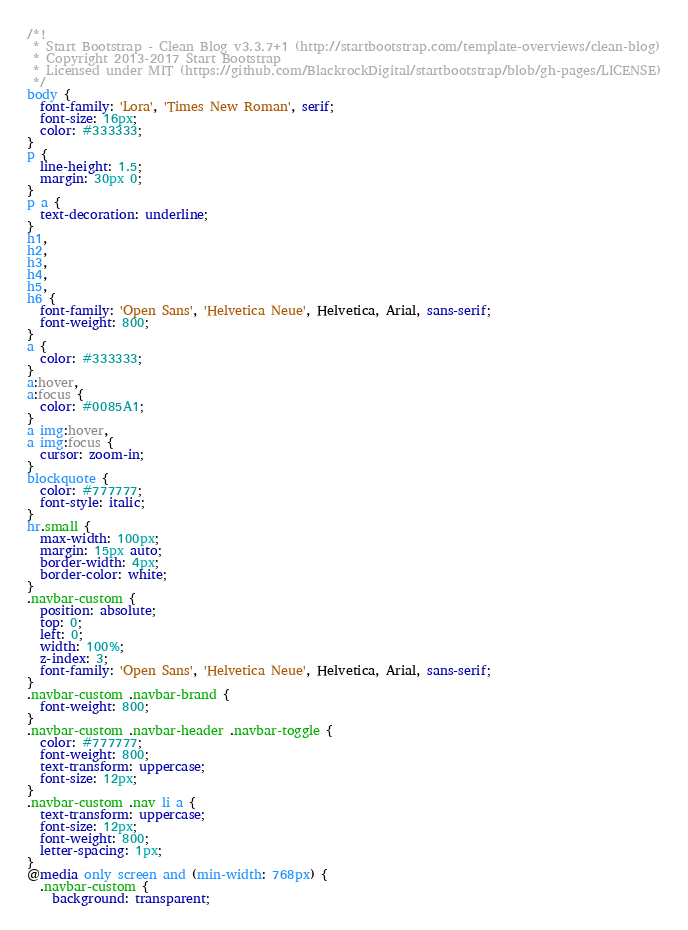<code> <loc_0><loc_0><loc_500><loc_500><_CSS_>/*!
 * Start Bootstrap - Clean Blog v3.3.7+1 (http://startbootstrap.com/template-overviews/clean-blog)
 * Copyright 2013-2017 Start Bootstrap
 * Licensed under MIT (https://github.com/BlackrockDigital/startbootstrap/blob/gh-pages/LICENSE)
 */
body {
  font-family: 'Lora', 'Times New Roman', serif;
  font-size: 16px;
  color: #333333;
}
p {
  line-height: 1.5;
  margin: 30px 0;
}
p a {
  text-decoration: underline;
}
h1,
h2,
h3,
h4,
h5,
h6 {
  font-family: 'Open Sans', 'Helvetica Neue', Helvetica, Arial, sans-serif;
  font-weight: 800;
}
a {
  color: #333333;
}
a:hover,
a:focus {
  color: #0085A1;
}
a img:hover,
a img:focus {
  cursor: zoom-in;
}
blockquote {
  color: #777777;
  font-style: italic;
}
hr.small {
  max-width: 100px;
  margin: 15px auto;
  border-width: 4px;
  border-color: white;
}
.navbar-custom {
  position: absolute;
  top: 0;
  left: 0;
  width: 100%;
  z-index: 3;
  font-family: 'Open Sans', 'Helvetica Neue', Helvetica, Arial, sans-serif;
}
.navbar-custom .navbar-brand {
  font-weight: 800;
}
.navbar-custom .navbar-header .navbar-toggle {
  color: #777777;
  font-weight: 800;
  text-transform: uppercase;
  font-size: 12px;
}
.navbar-custom .nav li a {
  text-transform: uppercase;
  font-size: 12px;
  font-weight: 800;
  letter-spacing: 1px;
}
@media only screen and (min-width: 768px) {
  .navbar-custom {
    background: transparent;</code> 